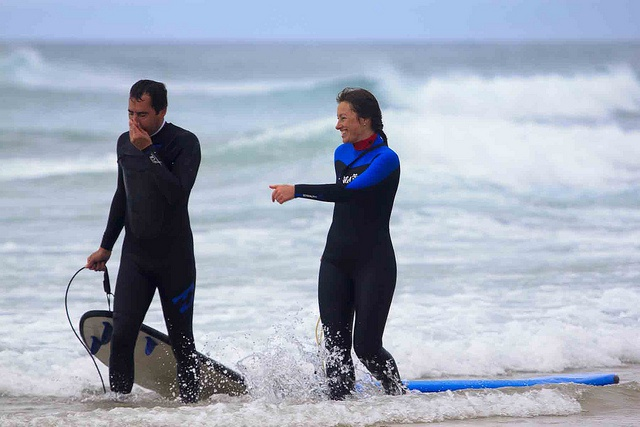Describe the objects in this image and their specific colors. I can see people in lavender, black, maroon, gray, and lightgray tones, people in lavender, black, gray, navy, and darkblue tones, surfboard in lavender, gray, black, and darkgray tones, and surfboard in lavender, lightblue, blue, and gray tones in this image. 